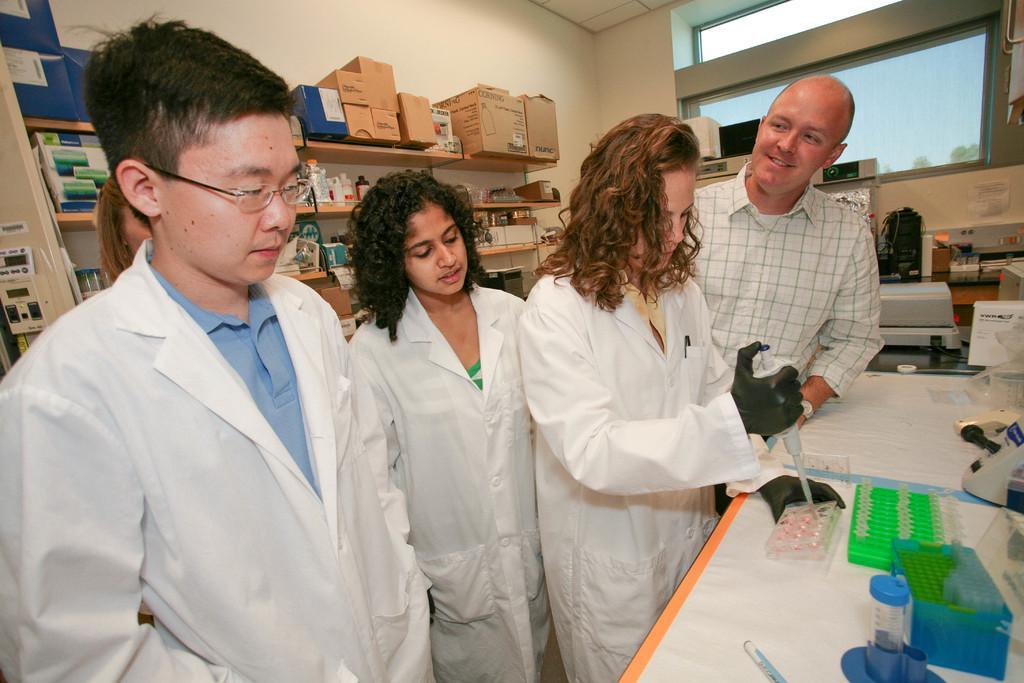Please provide a concise description of this image. This picture describes about group of people, they are standing, in front of them we can find a box and some other things on the table, behind to them we can see few boxes and medicines in the racks. 